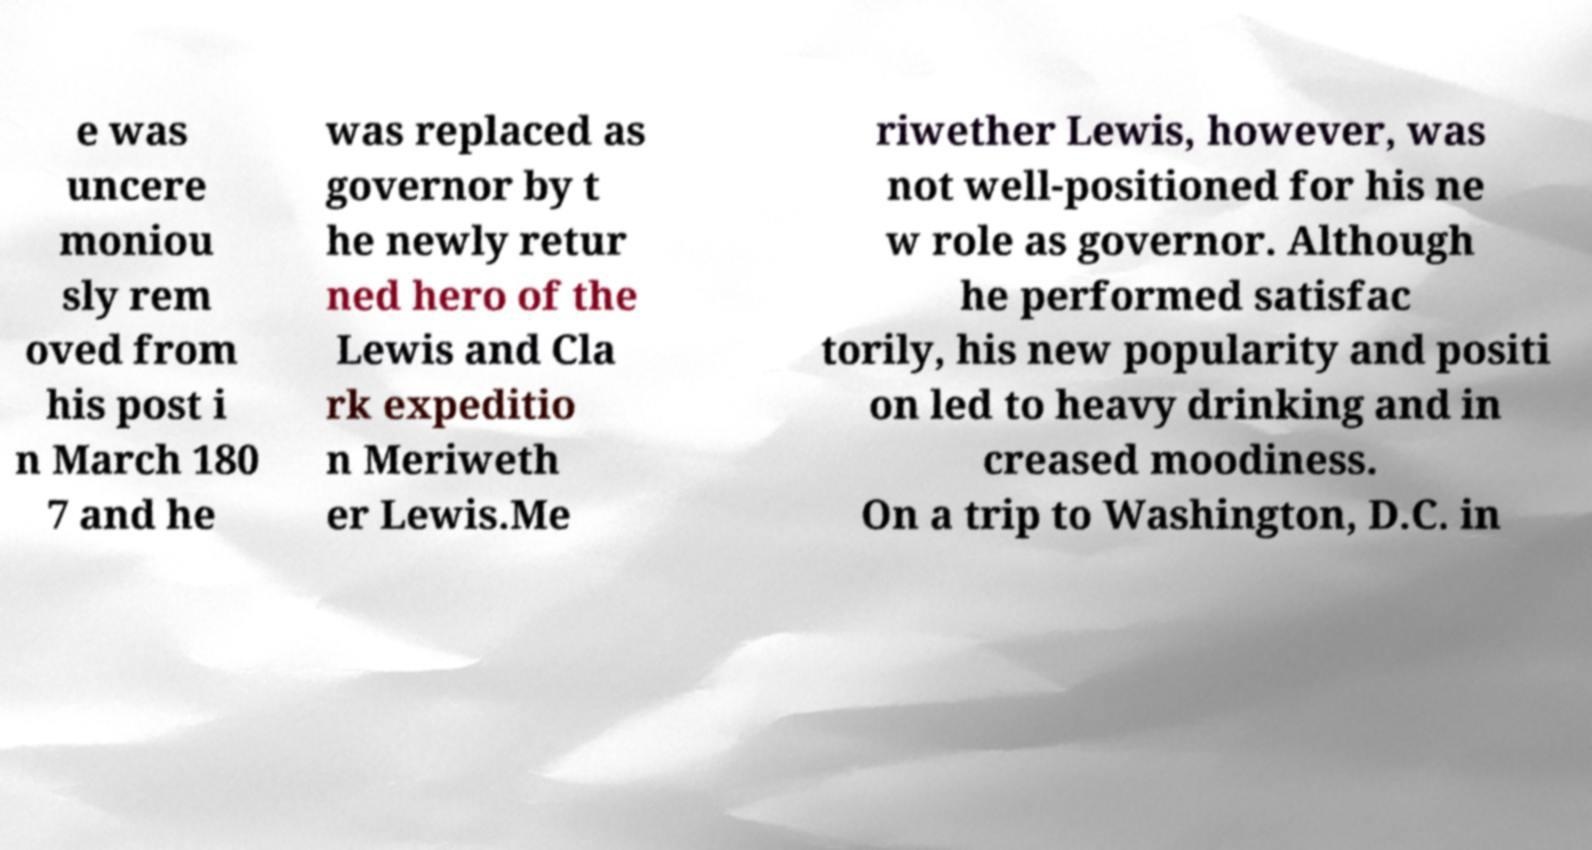Can you read and provide the text displayed in the image?This photo seems to have some interesting text. Can you extract and type it out for me? e was uncere moniou sly rem oved from his post i n March 180 7 and he was replaced as governor by t he newly retur ned hero of the Lewis and Cla rk expeditio n Meriweth er Lewis.Me riwether Lewis, however, was not well-positioned for his ne w role as governor. Although he performed satisfac torily, his new popularity and positi on led to heavy drinking and in creased moodiness. On a trip to Washington, D.C. in 